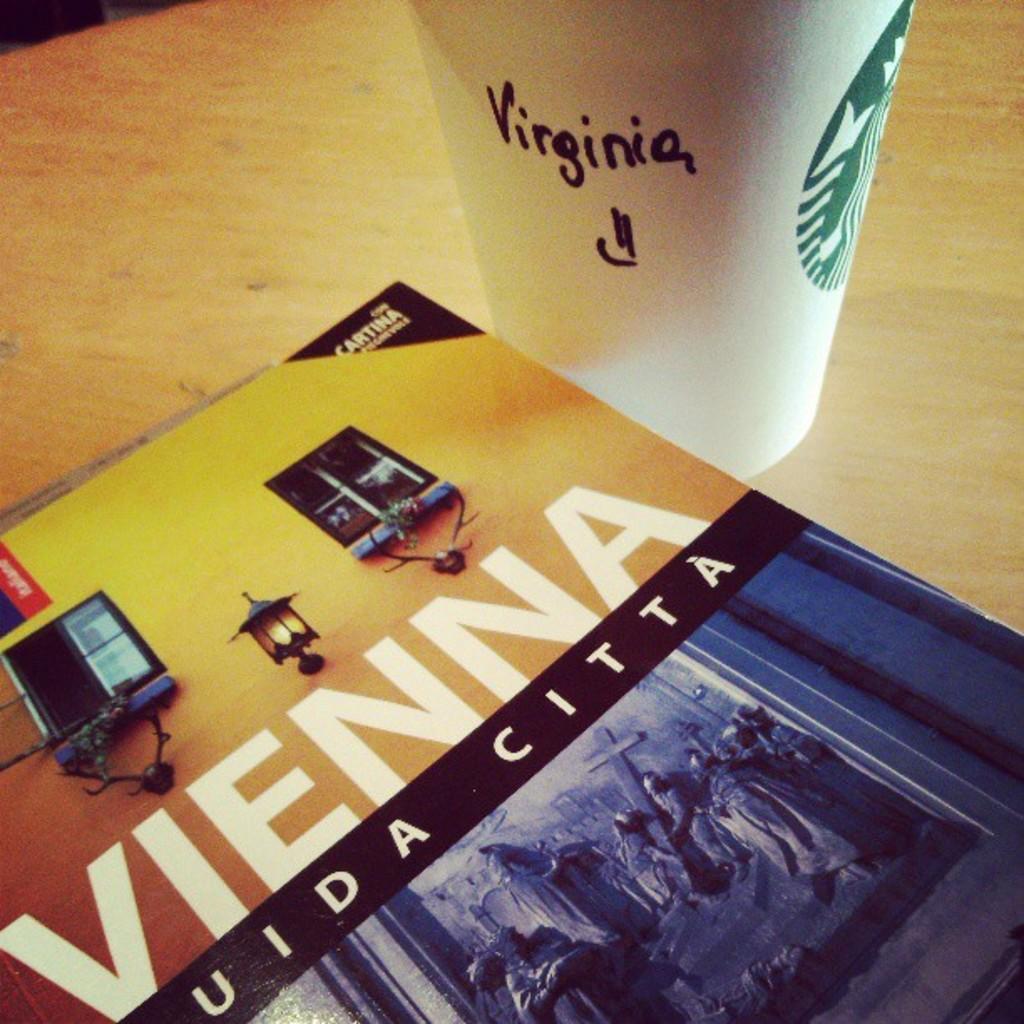What city does this book discuss?
Your answer should be compact. Vienna. 